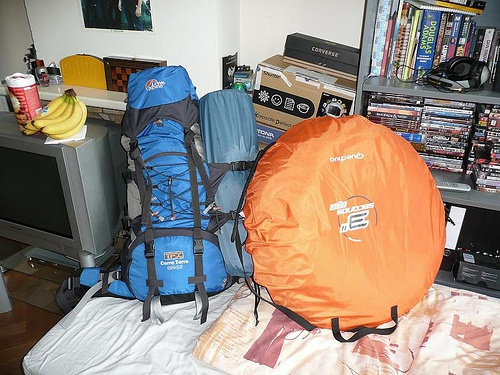Describe the objects in this image and their specific colors. I can see bed in gray, lightgray, lightpink, darkgray, and tan tones, backpack in gray, lightblue, and black tones, tv in gray, black, and darkgray tones, book in gray, black, lightgray, and darkgray tones, and banana in gray, khaki, tan, and olive tones in this image. 